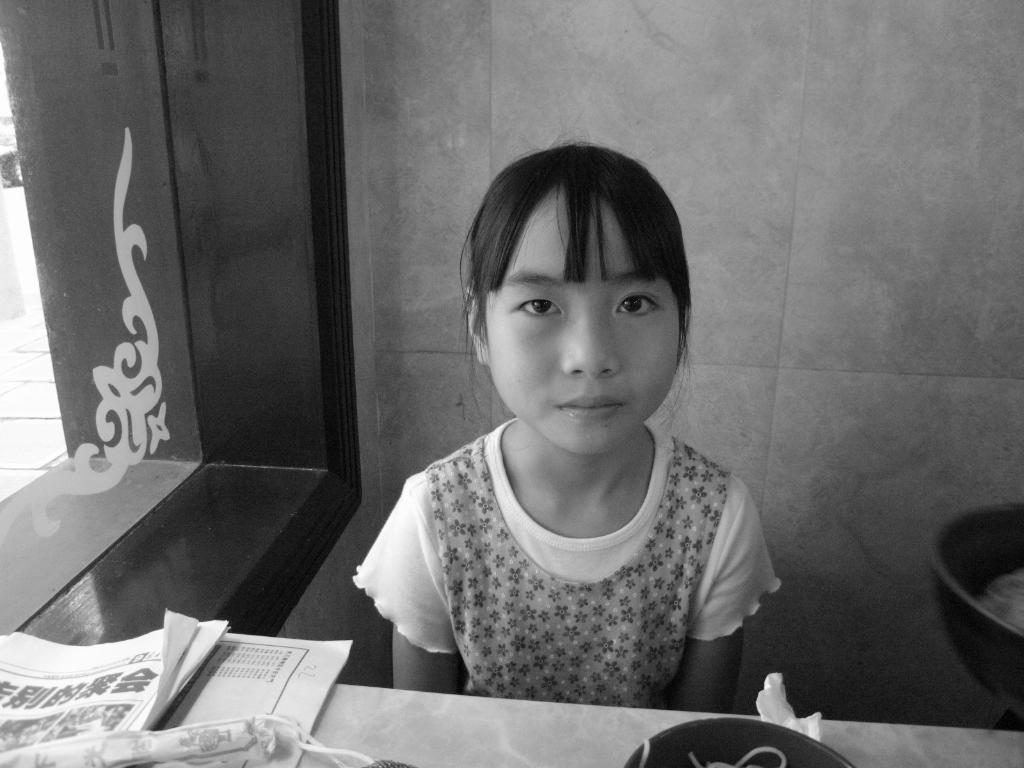Who is the main subject in the image? There is a girl in the image. Can you describe the girl's hairstyle? The girl has bangs. What objects are at the front of the image? There are papers at the front of the image. What can be seen on the left side of the image? There is a glass window on the left side of the image. What type of food is the girl cooking in the image? There is no indication in the image that the girl is cooking any food, so it cannot be determined from the picture. 